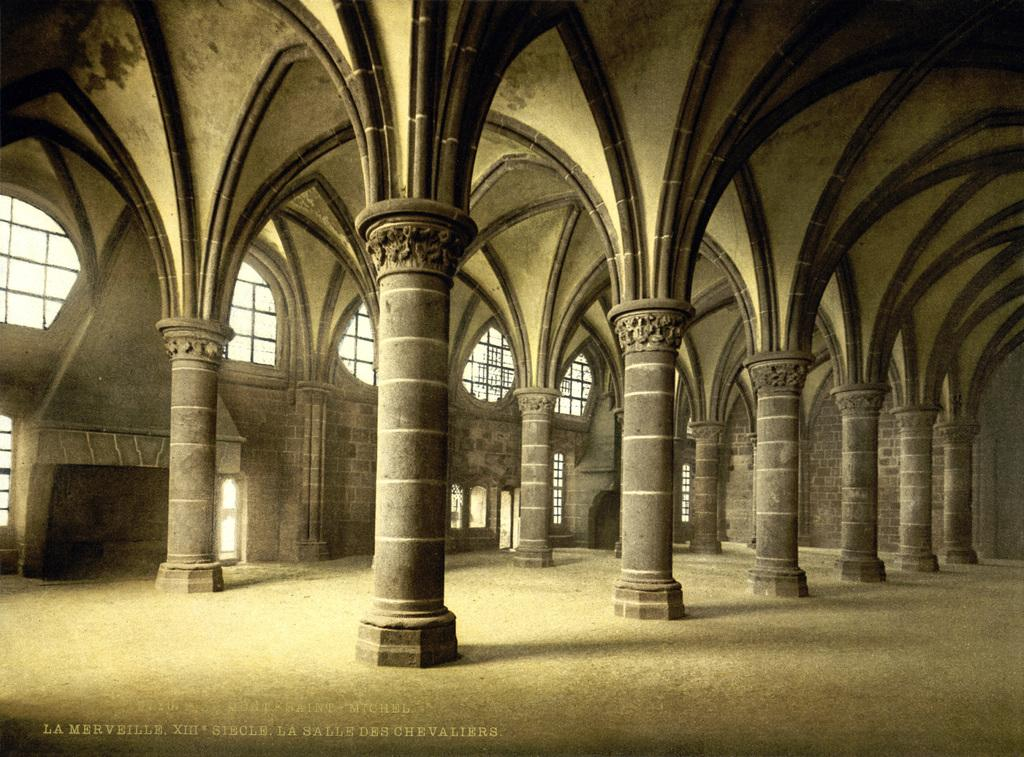What architectural features can be seen in the image? There are pillars in the image. What can be seen through the pillars in the image? There are windows in the image. What illuminates the space in the image? There are lights in the image. What type of apparel is the doll wearing in the image? There is no doll present in the image, so it is not possible to determine what type of apparel the doll might be wearing. 